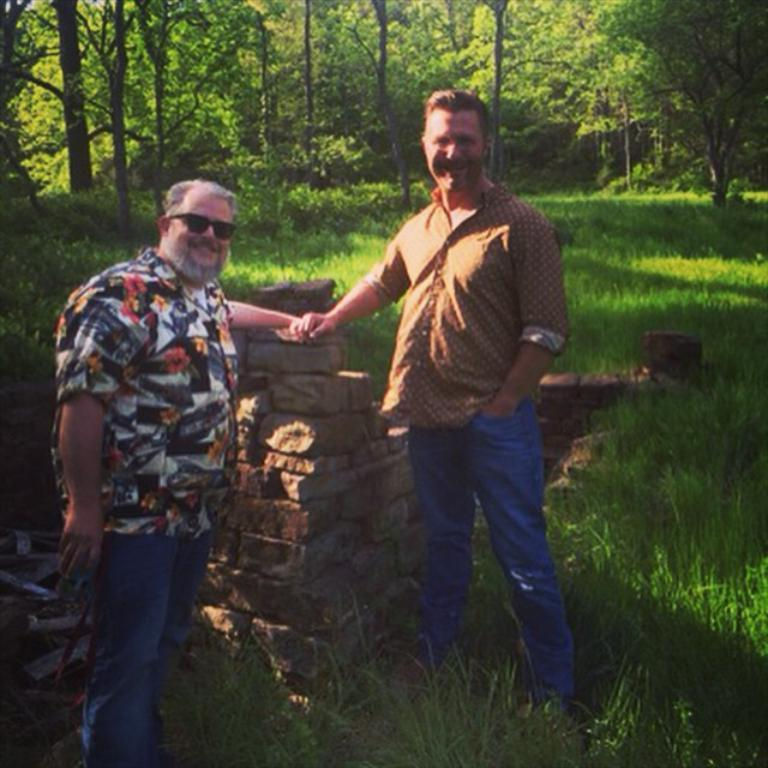How many people are in the image? There are two persons standing in the image. What is the facial expression of the persons in the image? The persons are smiling. What type of material can be seen in the image? There are bricks visible in the image. What type of vegetation is present in the image? There is grass in the image. What can be seen in the background of the image? There are trees in the background of the image. What type of brass instrument is being played by one of the persons in the image? There is no brass instrument present in the image; the persons are simply standing and smiling. 